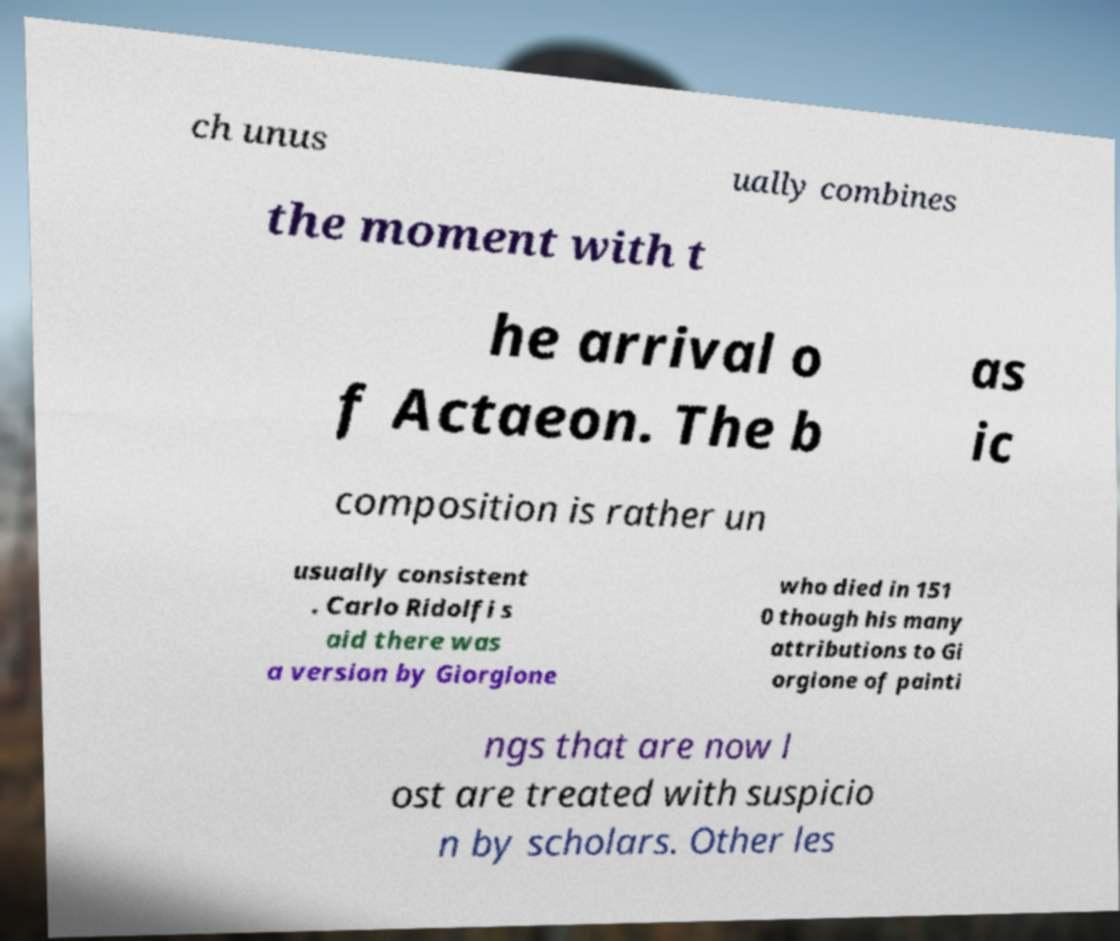There's text embedded in this image that I need extracted. Can you transcribe it verbatim? ch unus ually combines the moment with t he arrival o f Actaeon. The b as ic composition is rather un usually consistent . Carlo Ridolfi s aid there was a version by Giorgione who died in 151 0 though his many attributions to Gi orgione of painti ngs that are now l ost are treated with suspicio n by scholars. Other les 